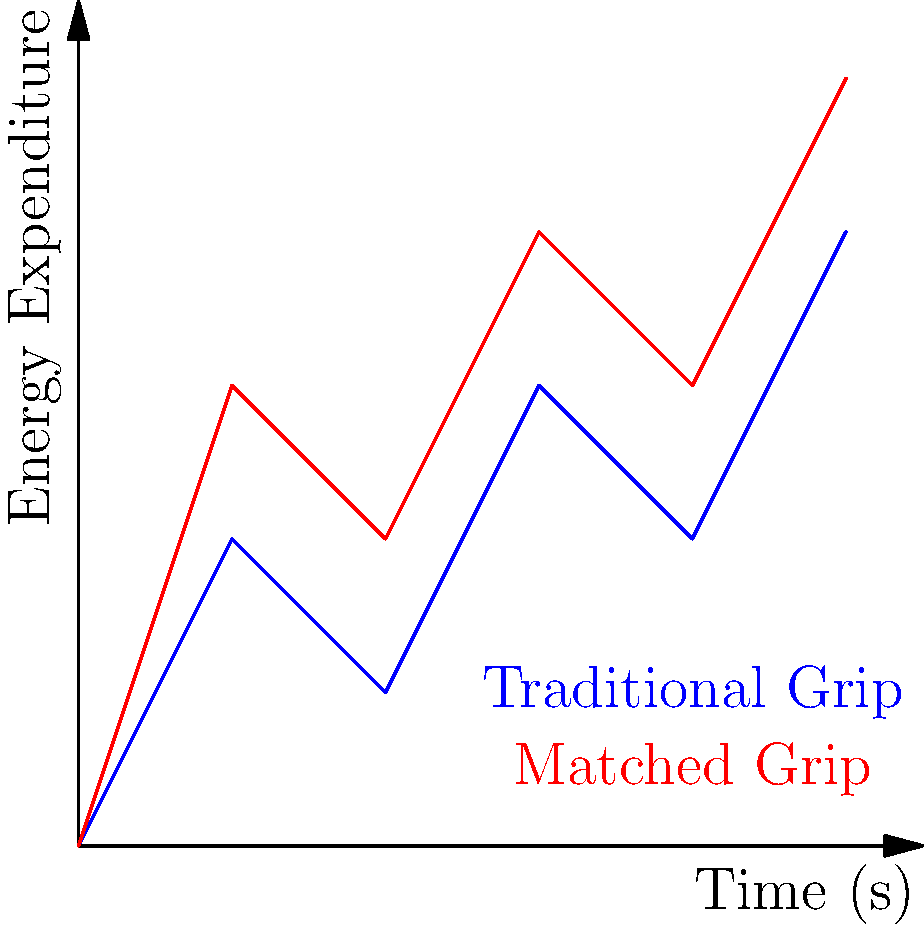As a drummer incorporating metal elements into your indie tracks, you're exploring different drumming techniques. The graph shows energy expenditure over time for two common drum grips: traditional and matched. Based on the biomechanical efficiency depicted, which grip would likely allow for longer, more intense drumming sessions with less fatigue? To determine which grip allows for longer, more intense drumming sessions with less fatigue, we need to analyze the energy expenditure over time for both grips:

1. Observe the graph:
   - Blue line represents the Traditional Grip
   - Red line represents the Matched Grip

2. Compare the slopes:
   - The Matched Grip (red) has a steeper overall slope
   - The Traditional Grip (blue) has a more gradual slope

3. Interpret the slopes:
   - A steeper slope indicates higher energy expenditure over time
   - A more gradual slope indicates lower energy expenditure over time

4. Consider the implications:
   - Lower energy expenditure leads to less fatigue over time
   - Less fatigue allows for longer, more intense drumming sessions

5. Analyze the biomechanical efficiency:
   - The Traditional Grip shows lower energy expenditure
   - This suggests better biomechanical efficiency for prolonged drumming

6. Conclusion:
   - The Traditional Grip, with its lower energy expenditure, would likely allow for longer, more intense drumming sessions with less fatigue.
Answer: Traditional Grip 